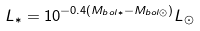Convert formula to latex. <formula><loc_0><loc_0><loc_500><loc_500>L _ { \ast } = 1 0 ^ { - 0 . 4 ( M _ { b o l \ast } - M _ { b o l \odot } ) } L _ { \odot }</formula> 